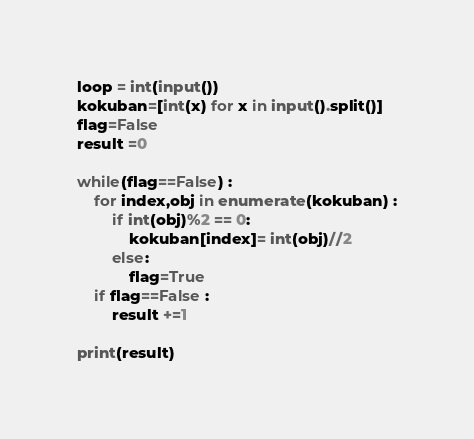<code> <loc_0><loc_0><loc_500><loc_500><_Python_>loop = int(input())
kokuban=[int(x) for x in input().split()]
flag=False
result =0

while(flag==False) :
    for index,obj in enumerate(kokuban) :
        if int(obj)%2 == 0:
            kokuban[index]= int(obj)//2
        else:
            flag=True
    if flag==False :
        result +=1

print(result)
</code> 